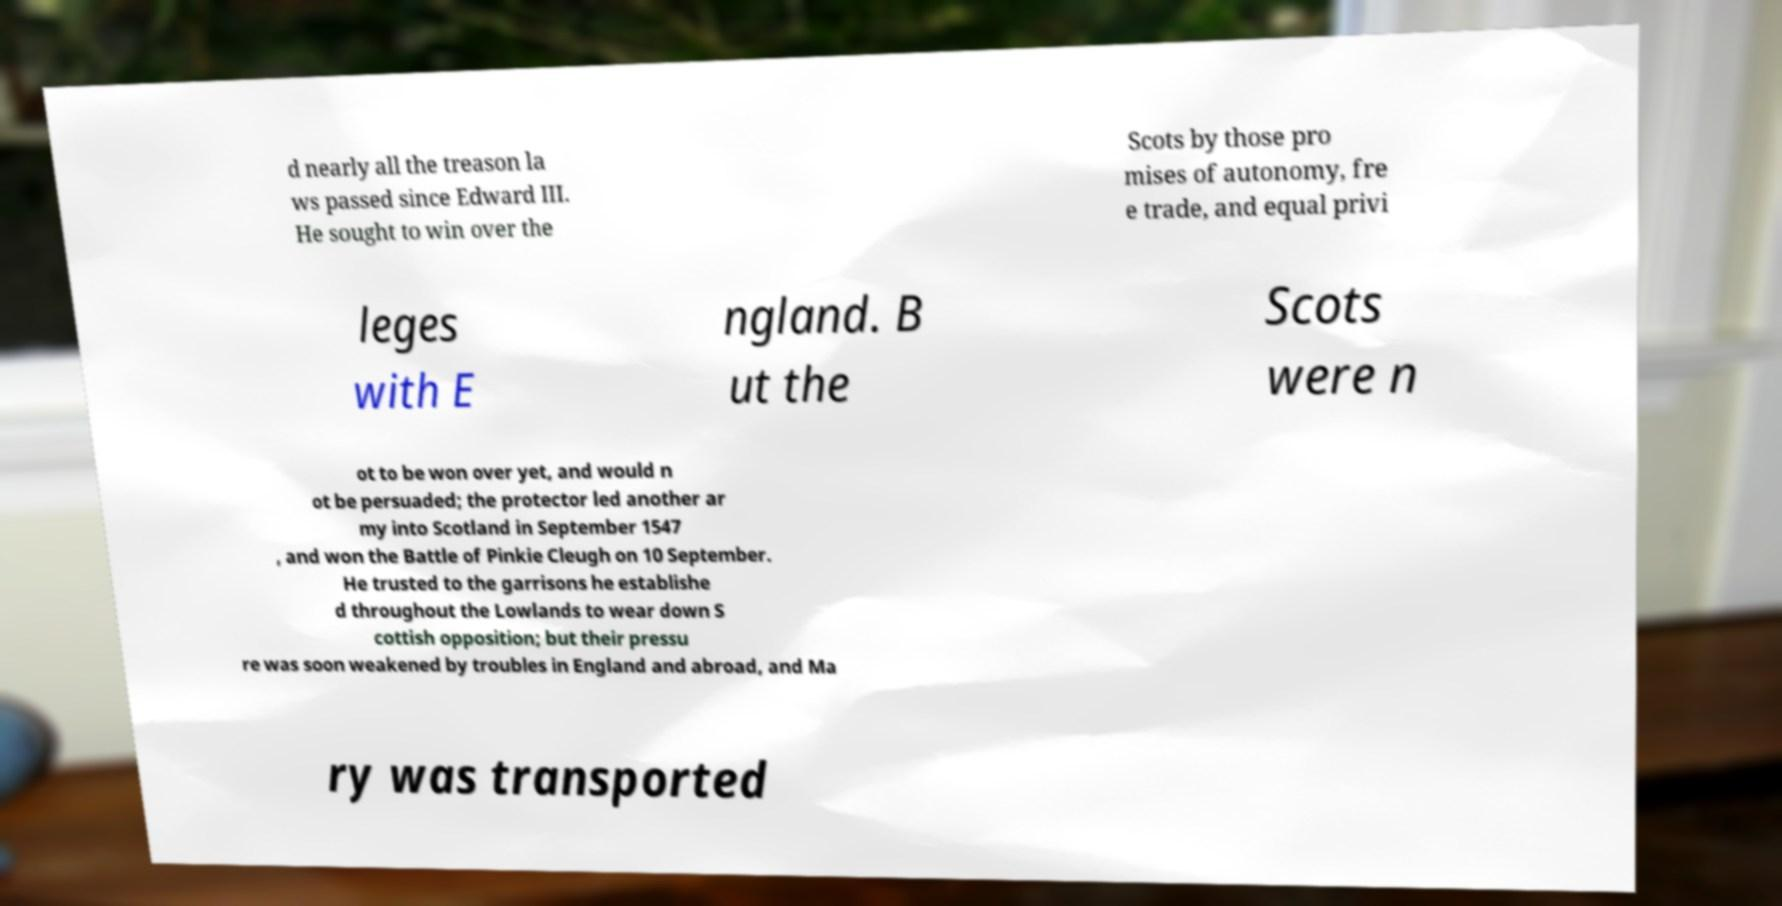Please identify and transcribe the text found in this image. d nearly all the treason la ws passed since Edward III. He sought to win over the Scots by those pro mises of autonomy, fre e trade, and equal privi leges with E ngland. B ut the Scots were n ot to be won over yet, and would n ot be persuaded; the protector led another ar my into Scotland in September 1547 , and won the Battle of Pinkie Cleugh on 10 September. He trusted to the garrisons he establishe d throughout the Lowlands to wear down S cottish opposition; but their pressu re was soon weakened by troubles in England and abroad, and Ma ry was transported 